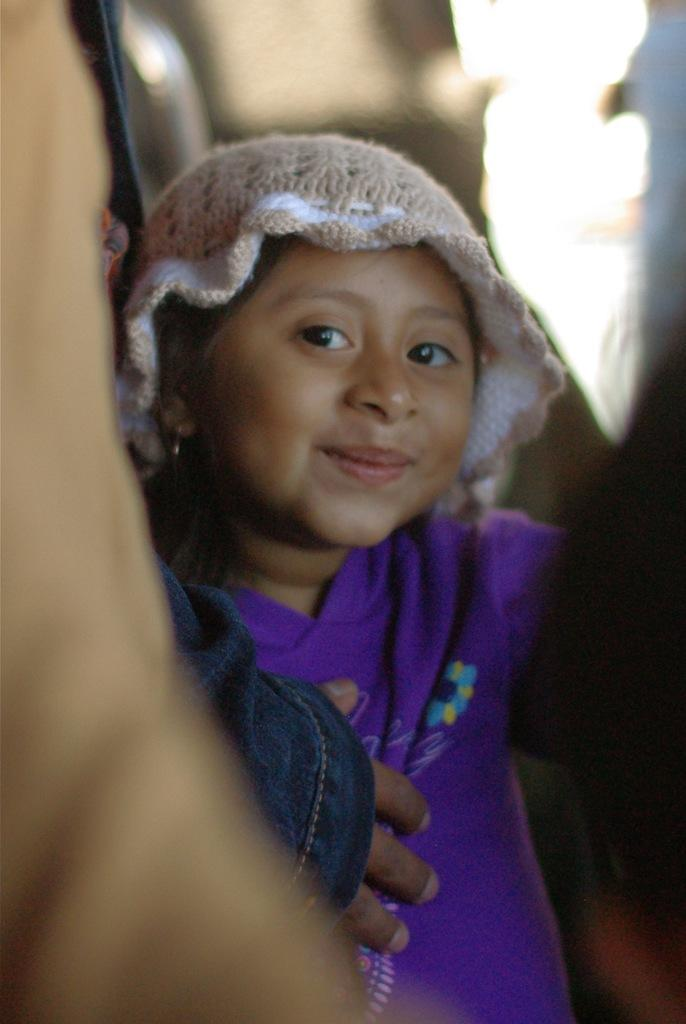Who is the main subject in the picture? There is a girl in the picture. What is the girl doing in the picture? The girl is standing in the picture. What is the girl's facial expression in the picture? The girl is smiling in the picture. What is the girl wearing on her head in the picture? The girl is wearing a cap in the picture. Can you describe the background of the picture? The backdrop is blurred in the picture. What type of cheese is the girl holding in the picture? There is no cheese present in the picture; the girl is wearing a cap and smiling. 